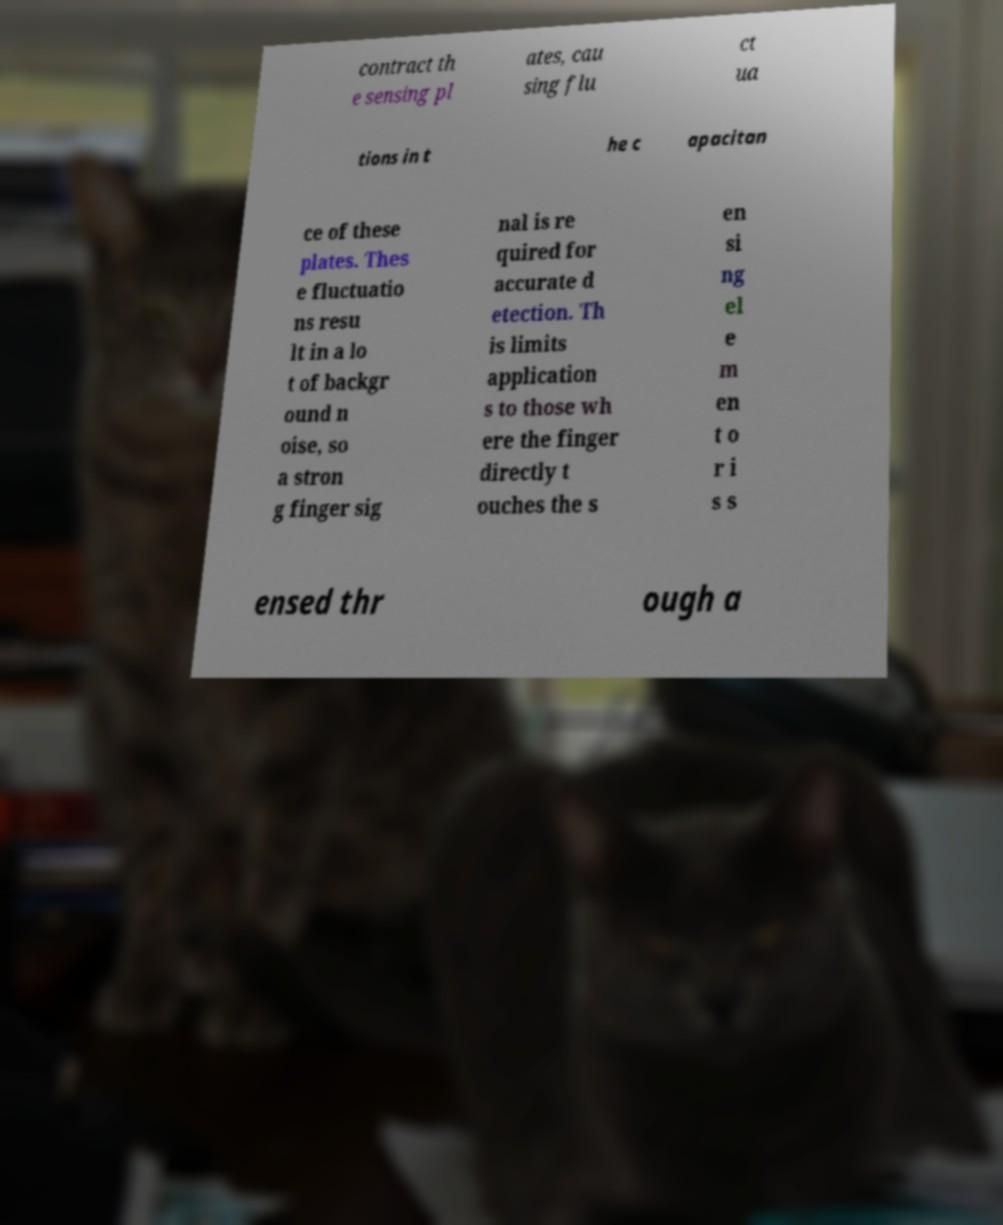Could you extract and type out the text from this image? contract th e sensing pl ates, cau sing flu ct ua tions in t he c apacitan ce of these plates. Thes e fluctuatio ns resu lt in a lo t of backgr ound n oise, so a stron g finger sig nal is re quired for accurate d etection. Th is limits application s to those wh ere the finger directly t ouches the s en si ng el e m en t o r i s s ensed thr ough a 